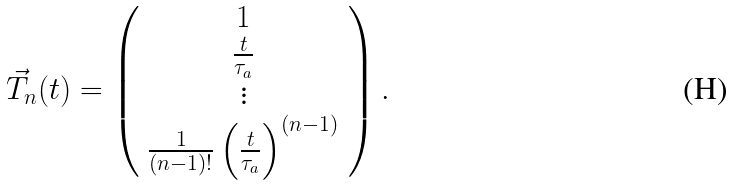Convert formula to latex. <formula><loc_0><loc_0><loc_500><loc_500>\vec { T } _ { n } ( t ) = \left ( \begin{array} { c } 1 \\ \frac { t } { \tau _ { a } } \\ \vdots \\ \frac { 1 } { ( n - 1 ) ! } \left ( \frac { t } { \tau _ { a } } \right ) ^ { ( n - 1 ) } \end{array} \right ) .</formula> 